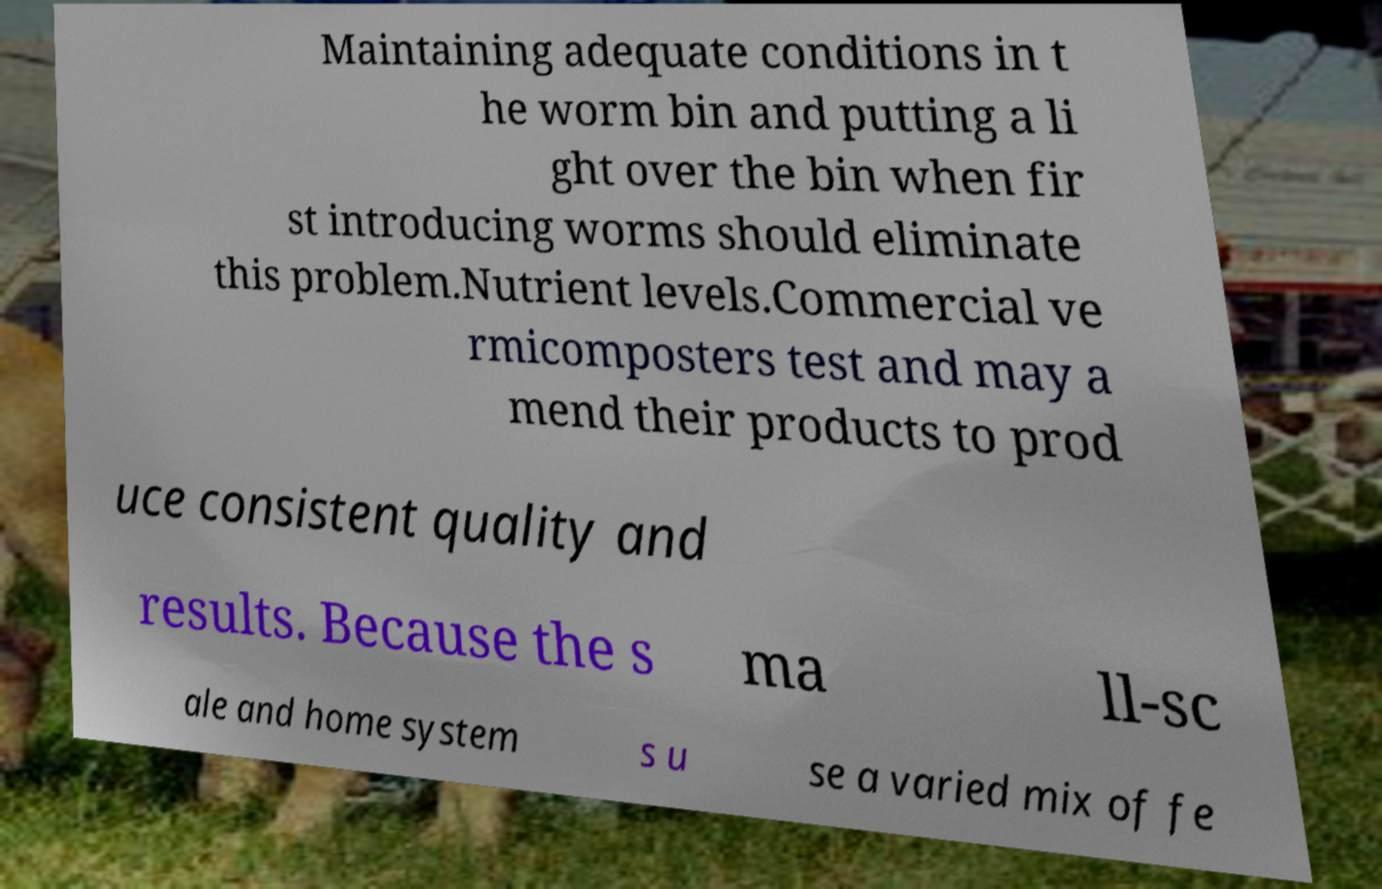Can you read and provide the text displayed in the image?This photo seems to have some interesting text. Can you extract and type it out for me? Maintaining adequate conditions in t he worm bin and putting a li ght over the bin when fir st introducing worms should eliminate this problem.Nutrient levels.Commercial ve rmicomposters test and may a mend their products to prod uce consistent quality and results. Because the s ma ll-sc ale and home system s u se a varied mix of fe 